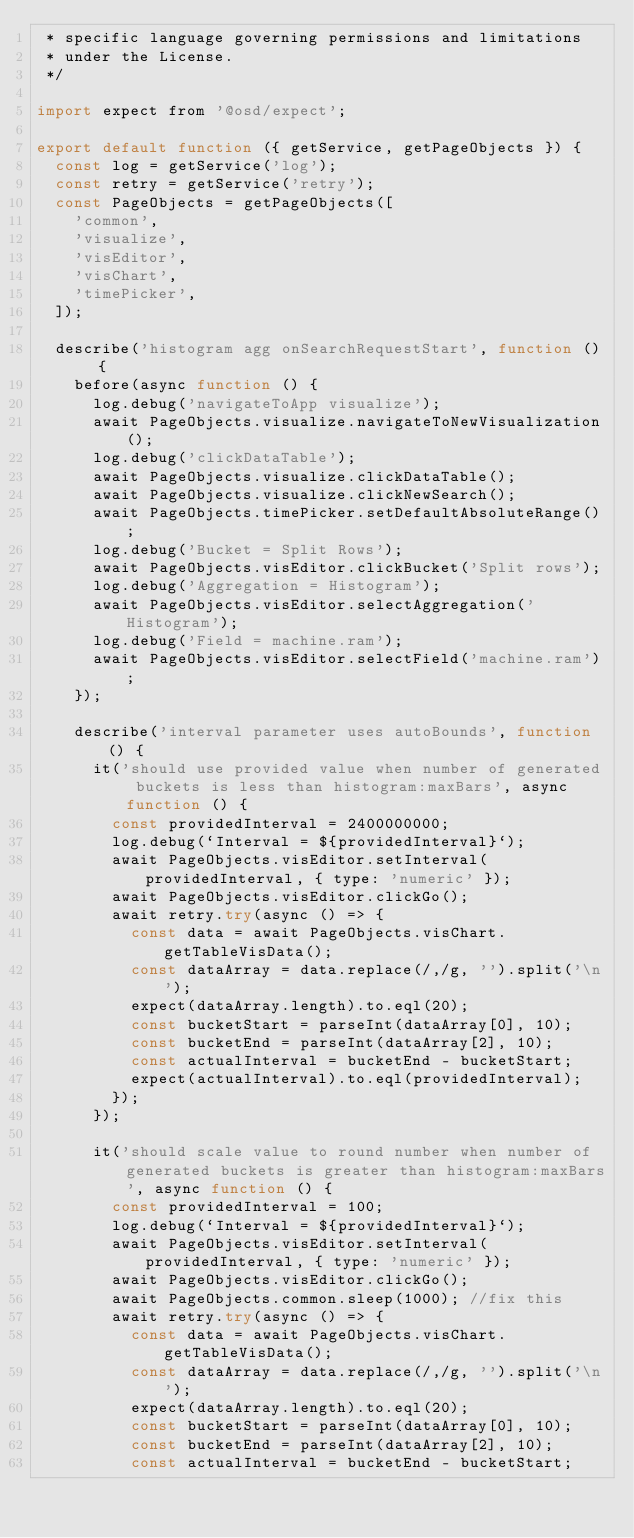<code> <loc_0><loc_0><loc_500><loc_500><_JavaScript_> * specific language governing permissions and limitations
 * under the License.
 */

import expect from '@osd/expect';

export default function ({ getService, getPageObjects }) {
  const log = getService('log');
  const retry = getService('retry');
  const PageObjects = getPageObjects([
    'common',
    'visualize',
    'visEditor',
    'visChart',
    'timePicker',
  ]);

  describe('histogram agg onSearchRequestStart', function () {
    before(async function () {
      log.debug('navigateToApp visualize');
      await PageObjects.visualize.navigateToNewVisualization();
      log.debug('clickDataTable');
      await PageObjects.visualize.clickDataTable();
      await PageObjects.visualize.clickNewSearch();
      await PageObjects.timePicker.setDefaultAbsoluteRange();
      log.debug('Bucket = Split Rows');
      await PageObjects.visEditor.clickBucket('Split rows');
      log.debug('Aggregation = Histogram');
      await PageObjects.visEditor.selectAggregation('Histogram');
      log.debug('Field = machine.ram');
      await PageObjects.visEditor.selectField('machine.ram');
    });

    describe('interval parameter uses autoBounds', function () {
      it('should use provided value when number of generated buckets is less than histogram:maxBars', async function () {
        const providedInterval = 2400000000;
        log.debug(`Interval = ${providedInterval}`);
        await PageObjects.visEditor.setInterval(providedInterval, { type: 'numeric' });
        await PageObjects.visEditor.clickGo();
        await retry.try(async () => {
          const data = await PageObjects.visChart.getTableVisData();
          const dataArray = data.replace(/,/g, '').split('\n');
          expect(dataArray.length).to.eql(20);
          const bucketStart = parseInt(dataArray[0], 10);
          const bucketEnd = parseInt(dataArray[2], 10);
          const actualInterval = bucketEnd - bucketStart;
          expect(actualInterval).to.eql(providedInterval);
        });
      });

      it('should scale value to round number when number of generated buckets is greater than histogram:maxBars', async function () {
        const providedInterval = 100;
        log.debug(`Interval = ${providedInterval}`);
        await PageObjects.visEditor.setInterval(providedInterval, { type: 'numeric' });
        await PageObjects.visEditor.clickGo();
        await PageObjects.common.sleep(1000); //fix this
        await retry.try(async () => {
          const data = await PageObjects.visChart.getTableVisData();
          const dataArray = data.replace(/,/g, '').split('\n');
          expect(dataArray.length).to.eql(20);
          const bucketStart = parseInt(dataArray[0], 10);
          const bucketEnd = parseInt(dataArray[2], 10);
          const actualInterval = bucketEnd - bucketStart;</code> 